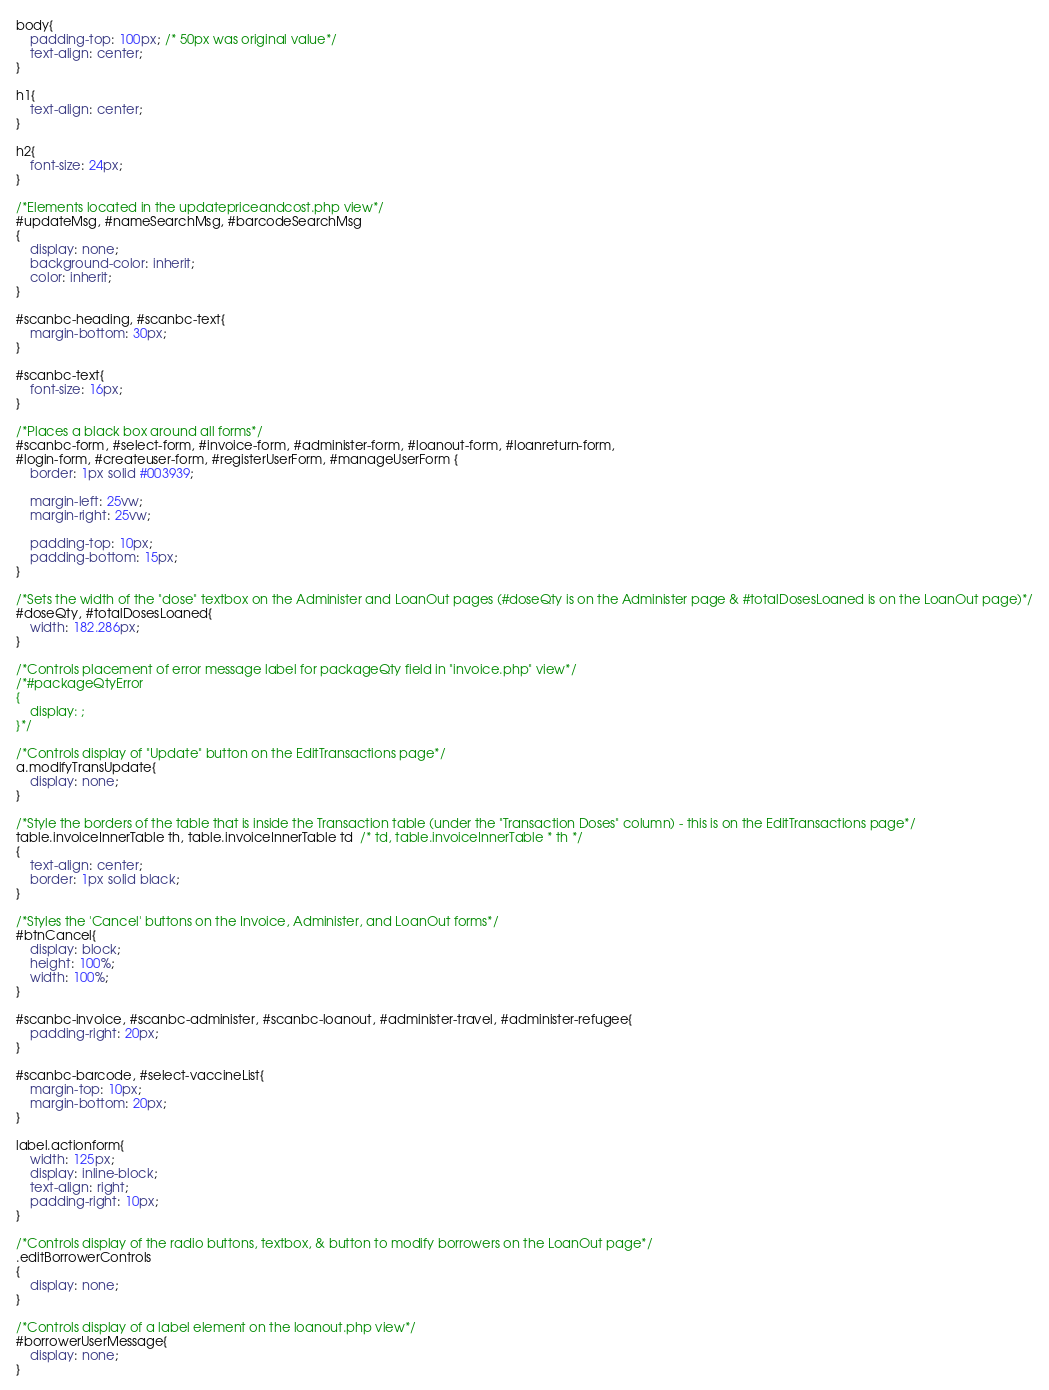Convert code to text. <code><loc_0><loc_0><loc_500><loc_500><_CSS_>body{
	padding-top: 100px; /* 50px was original value*/
	text-align: center;
}

h1{
	text-align: center;
}

h2{
	font-size: 24px;
}

/*Elements located in the updatepriceandcost.php view*/
#updateMsg, #nameSearchMsg, #barcodeSearchMsg
{
	display: none;
	background-color: inherit;
	color: inherit;
}

#scanbc-heading, #scanbc-text{
	margin-bottom: 30px;
}

#scanbc-text{
	font-size: 16px;
}

/*Places a black box around all forms*/
#scanbc-form, #select-form, #invoice-form, #administer-form, #loanout-form, #loanreturn-form, 
#login-form, #createuser-form, #registerUserForm, #manageUserForm {
	border: 1px solid #003939;
	
	margin-left: 25vw;
	margin-right: 25vw;

	padding-top: 10px;
	padding-bottom: 15px;
}

/*Sets the width of the "dose" textbox on the Administer and LoanOut pages (#doseQty is on the Administer page & #totalDosesLoaned is on the LoanOut page)*/
#doseQty, #totalDosesLoaned{
	width: 182.286px;
}

/*Controls placement of error message label for packageQty field in "invoice.php" view*/
/*#packageQtyError
{
	display: ;
}*/

/*Controls display of "Update" button on the EditTransactions page*/
a.modifyTransUpdate{
	display: none;
}

/*Style the borders of the table that is inside the Transaction table (under the "Transaction Doses" column) - this is on the EditTransactions page*/
table.invoiceInnerTable th, table.invoiceInnerTable td  /* td, table.invoiceInnerTable * th */
{
	text-align: center;
	border: 1px solid black;
}

/*Styles the 'Cancel' buttons on the Invoice, Administer, and LoanOut forms*/
#btnCancel{
	display: block;
	height: 100%;
	width: 100%;
}

#scanbc-invoice, #scanbc-administer, #scanbc-loanout, #administer-travel, #administer-refugee{
	padding-right: 20px;
}

#scanbc-barcode, #select-vaccineList{
	margin-top: 10px;
	margin-bottom: 20px;
}

label.actionform{
	width: 125px;
	display: inline-block;
	text-align: right;
	padding-right: 10px;
}

/*Controls display of the radio buttons, textbox, & button to modify borrowers on the LoanOut page*/
.editBorrowerControls
{
	display: none;
}

/*Controls display of a label element on the loanout.php view*/
#borrowerUserMessage{
	display: none;
}
</code> 